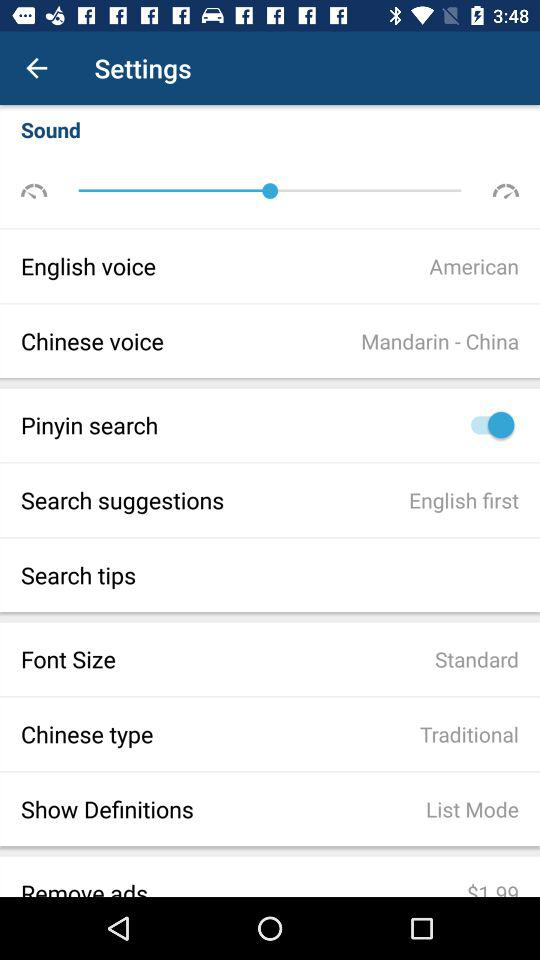What is the status of "Pinyin search"? The status of "Pinyin search" is "on". 